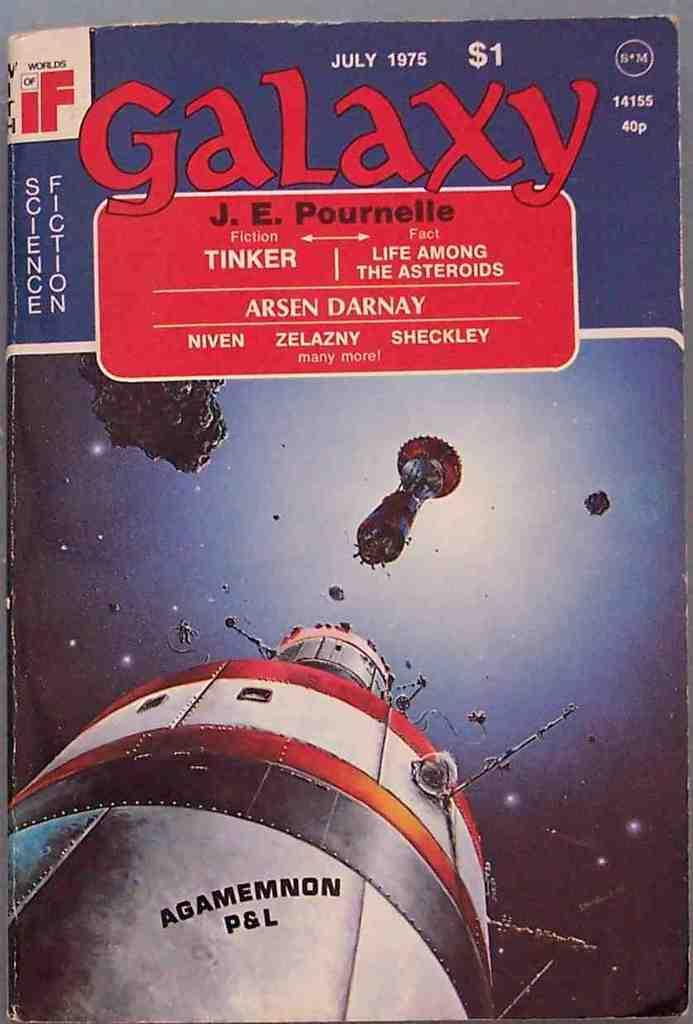What type of visual is the image? The image is a poster. What can be found on the poster besides the visual elements? There is text on the poster. What else is depicted on the poster besides the text? There are objects on the poster. How many deer are visible on the poster? There are no deer present on the poster. What type of pie is being served on the poster? There is no pie depicted on the poster. 